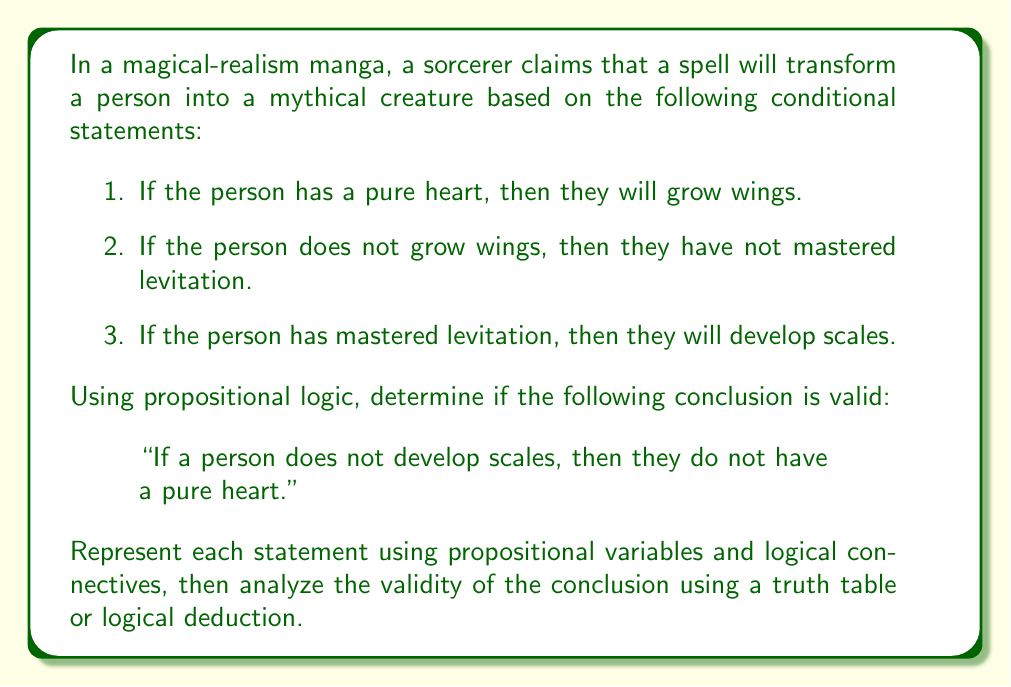Provide a solution to this math problem. Let's approach this problem step by step using propositional logic:

1. First, we'll assign propositional variables to each statement:
   $P$: The person has a pure heart
   $W$: The person grows wings
   $L$: The person has mastered levitation
   $S$: The person develops scales

2. Now, we can represent the given conditional statements using logical connectives:
   Statement 1: $P \rightarrow W$
   Statement 2: $\neg W \rightarrow \neg L$
   Statement 3: $L \rightarrow S$

3. The conclusion we need to evaluate is:
   $\neg S \rightarrow \neg P$

4. To determine if this conclusion is valid, we need to check if it logically follows from the given premises. We can do this using contraposition and logical deduction:

   a) From Statement 3: $L \rightarrow S$
      Contrapositive: $\neg S \rightarrow \neg L$

   b) From Statement 2: $\neg W \rightarrow \neg L$
      Contrapositive: $L \rightarrow W$

   c) From (a) and (b), we can deduce:
      $\neg S \rightarrow \neg L \rightarrow W$

   d) From Statement 1: $P \rightarrow W$
      Contrapositive: $\neg W \rightarrow \neg P$

   e) However, we cannot logically deduce $\neg S \rightarrow \neg P$ from these statements.

5. To further illustrate this, we can construct a partial truth table:

   $$
   \begin{array}{|c|c|c|c|c|}
   \hline
   P & W & L & S & \neg S \rightarrow \neg P \\
   \hline
   T & T & T & T & T \\
   T & T & T & F & F \\
   T & T & F & F & F \\
   T & F & F & F & F \\
   F & T & T & T & T \\
   F & T & T & F & T \\
   F & F & F & F & T \\
   \hline
   \end{array}
   $$

   This truth table shows that there are cases where $\neg S \rightarrow \neg P$ is false while all the premises are true (e.g., the second row).

Therefore, the conclusion "If a person does not develop scales, then they do not have a pure heart" is not logically valid based on the given premises.
Answer: The conclusion is not valid. The given premises do not logically guarantee that if a person does not develop scales, then they do not have a pure heart ($\neg S \rightarrow \neg P$). 